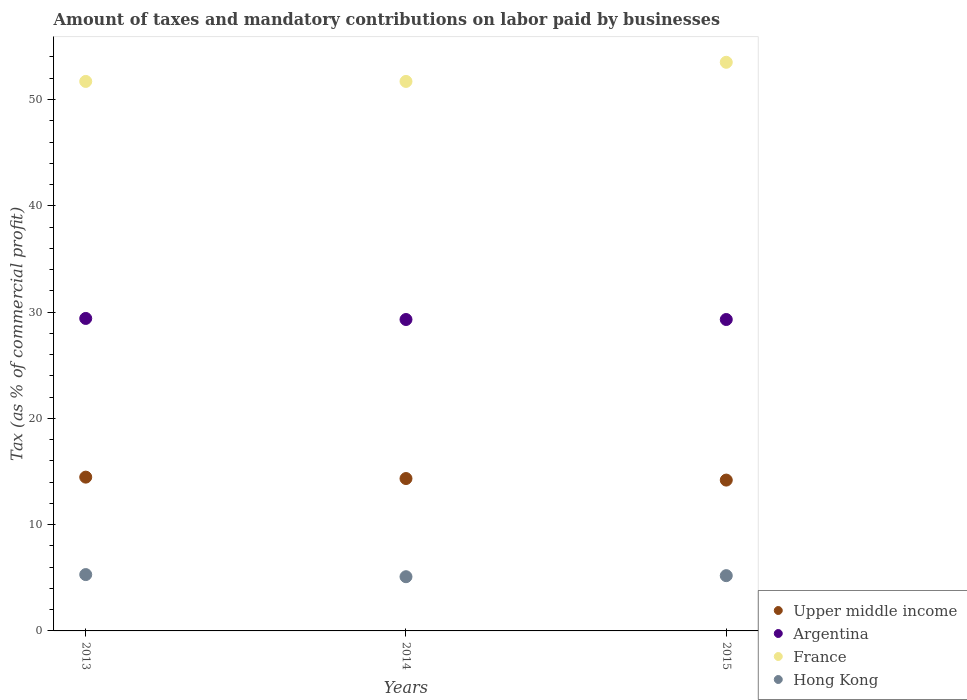What is the percentage of taxes paid by businesses in Hong Kong in 2013?
Your answer should be very brief. 5.3. Across all years, what is the maximum percentage of taxes paid by businesses in Hong Kong?
Offer a very short reply. 5.3. Across all years, what is the minimum percentage of taxes paid by businesses in France?
Give a very brief answer. 51.7. What is the total percentage of taxes paid by businesses in Upper middle income in the graph?
Your response must be concise. 43. What is the difference between the percentage of taxes paid by businesses in France in 2013 and that in 2014?
Offer a very short reply. 0. What is the difference between the percentage of taxes paid by businesses in Hong Kong in 2015 and the percentage of taxes paid by businesses in Upper middle income in 2014?
Provide a succinct answer. -9.14. What is the average percentage of taxes paid by businesses in Argentina per year?
Give a very brief answer. 29.33. In the year 2015, what is the difference between the percentage of taxes paid by businesses in Upper middle income and percentage of taxes paid by businesses in Argentina?
Give a very brief answer. -15.11. In how many years, is the percentage of taxes paid by businesses in Upper middle income greater than 32 %?
Provide a short and direct response. 0. What is the ratio of the percentage of taxes paid by businesses in Argentina in 2013 to that in 2015?
Your response must be concise. 1. Is the percentage of taxes paid by businesses in Hong Kong in 2013 less than that in 2014?
Your response must be concise. No. What is the difference between the highest and the second highest percentage of taxes paid by businesses in Hong Kong?
Keep it short and to the point. 0.1. What is the difference between the highest and the lowest percentage of taxes paid by businesses in Hong Kong?
Offer a terse response. 0.2. How many years are there in the graph?
Your response must be concise. 3. Does the graph contain grids?
Make the answer very short. No. How many legend labels are there?
Provide a short and direct response. 4. What is the title of the graph?
Provide a short and direct response. Amount of taxes and mandatory contributions on labor paid by businesses. What is the label or title of the Y-axis?
Provide a short and direct response. Tax (as % of commercial profit). What is the Tax (as % of commercial profit) in Upper middle income in 2013?
Your response must be concise. 14.47. What is the Tax (as % of commercial profit) in Argentina in 2013?
Your answer should be very brief. 29.4. What is the Tax (as % of commercial profit) of France in 2013?
Ensure brevity in your answer.  51.7. What is the Tax (as % of commercial profit) in Upper middle income in 2014?
Your response must be concise. 14.34. What is the Tax (as % of commercial profit) in Argentina in 2014?
Offer a terse response. 29.3. What is the Tax (as % of commercial profit) of France in 2014?
Your answer should be very brief. 51.7. What is the Tax (as % of commercial profit) in Hong Kong in 2014?
Offer a very short reply. 5.1. What is the Tax (as % of commercial profit) of Upper middle income in 2015?
Make the answer very short. 14.19. What is the Tax (as % of commercial profit) in Argentina in 2015?
Your response must be concise. 29.3. What is the Tax (as % of commercial profit) of France in 2015?
Offer a very short reply. 53.5. What is the Tax (as % of commercial profit) of Hong Kong in 2015?
Provide a succinct answer. 5.2. Across all years, what is the maximum Tax (as % of commercial profit) in Upper middle income?
Your answer should be very brief. 14.47. Across all years, what is the maximum Tax (as % of commercial profit) in Argentina?
Provide a short and direct response. 29.4. Across all years, what is the maximum Tax (as % of commercial profit) in France?
Offer a terse response. 53.5. Across all years, what is the maximum Tax (as % of commercial profit) in Hong Kong?
Ensure brevity in your answer.  5.3. Across all years, what is the minimum Tax (as % of commercial profit) of Upper middle income?
Give a very brief answer. 14.19. Across all years, what is the minimum Tax (as % of commercial profit) in Argentina?
Make the answer very short. 29.3. Across all years, what is the minimum Tax (as % of commercial profit) in France?
Ensure brevity in your answer.  51.7. Across all years, what is the minimum Tax (as % of commercial profit) in Hong Kong?
Provide a short and direct response. 5.1. What is the total Tax (as % of commercial profit) in Upper middle income in the graph?
Give a very brief answer. 43. What is the total Tax (as % of commercial profit) in Argentina in the graph?
Your answer should be very brief. 88. What is the total Tax (as % of commercial profit) of France in the graph?
Your response must be concise. 156.9. What is the total Tax (as % of commercial profit) of Hong Kong in the graph?
Offer a terse response. 15.6. What is the difference between the Tax (as % of commercial profit) of Upper middle income in 2013 and that in 2014?
Your response must be concise. 0.13. What is the difference between the Tax (as % of commercial profit) in Hong Kong in 2013 and that in 2014?
Your response must be concise. 0.2. What is the difference between the Tax (as % of commercial profit) of Upper middle income in 2013 and that in 2015?
Offer a terse response. 0.28. What is the difference between the Tax (as % of commercial profit) of France in 2013 and that in 2015?
Provide a short and direct response. -1.8. What is the difference between the Tax (as % of commercial profit) in Upper middle income in 2014 and that in 2015?
Your response must be concise. 0.15. What is the difference between the Tax (as % of commercial profit) in France in 2014 and that in 2015?
Offer a very short reply. -1.8. What is the difference between the Tax (as % of commercial profit) in Upper middle income in 2013 and the Tax (as % of commercial profit) in Argentina in 2014?
Keep it short and to the point. -14.83. What is the difference between the Tax (as % of commercial profit) in Upper middle income in 2013 and the Tax (as % of commercial profit) in France in 2014?
Provide a succinct answer. -37.23. What is the difference between the Tax (as % of commercial profit) in Upper middle income in 2013 and the Tax (as % of commercial profit) in Hong Kong in 2014?
Provide a succinct answer. 9.37. What is the difference between the Tax (as % of commercial profit) in Argentina in 2013 and the Tax (as % of commercial profit) in France in 2014?
Make the answer very short. -22.3. What is the difference between the Tax (as % of commercial profit) in Argentina in 2013 and the Tax (as % of commercial profit) in Hong Kong in 2014?
Offer a terse response. 24.3. What is the difference between the Tax (as % of commercial profit) of France in 2013 and the Tax (as % of commercial profit) of Hong Kong in 2014?
Your answer should be very brief. 46.6. What is the difference between the Tax (as % of commercial profit) of Upper middle income in 2013 and the Tax (as % of commercial profit) of Argentina in 2015?
Your answer should be compact. -14.83. What is the difference between the Tax (as % of commercial profit) in Upper middle income in 2013 and the Tax (as % of commercial profit) in France in 2015?
Your response must be concise. -39.03. What is the difference between the Tax (as % of commercial profit) in Upper middle income in 2013 and the Tax (as % of commercial profit) in Hong Kong in 2015?
Keep it short and to the point. 9.27. What is the difference between the Tax (as % of commercial profit) in Argentina in 2013 and the Tax (as % of commercial profit) in France in 2015?
Ensure brevity in your answer.  -24.1. What is the difference between the Tax (as % of commercial profit) in Argentina in 2013 and the Tax (as % of commercial profit) in Hong Kong in 2015?
Make the answer very short. 24.2. What is the difference between the Tax (as % of commercial profit) in France in 2013 and the Tax (as % of commercial profit) in Hong Kong in 2015?
Offer a very short reply. 46.5. What is the difference between the Tax (as % of commercial profit) in Upper middle income in 2014 and the Tax (as % of commercial profit) in Argentina in 2015?
Offer a very short reply. -14.96. What is the difference between the Tax (as % of commercial profit) of Upper middle income in 2014 and the Tax (as % of commercial profit) of France in 2015?
Give a very brief answer. -39.16. What is the difference between the Tax (as % of commercial profit) in Upper middle income in 2014 and the Tax (as % of commercial profit) in Hong Kong in 2015?
Provide a short and direct response. 9.14. What is the difference between the Tax (as % of commercial profit) in Argentina in 2014 and the Tax (as % of commercial profit) in France in 2015?
Ensure brevity in your answer.  -24.2. What is the difference between the Tax (as % of commercial profit) of Argentina in 2014 and the Tax (as % of commercial profit) of Hong Kong in 2015?
Your answer should be compact. 24.1. What is the difference between the Tax (as % of commercial profit) in France in 2014 and the Tax (as % of commercial profit) in Hong Kong in 2015?
Offer a very short reply. 46.5. What is the average Tax (as % of commercial profit) in Upper middle income per year?
Your answer should be compact. 14.33. What is the average Tax (as % of commercial profit) in Argentina per year?
Ensure brevity in your answer.  29.33. What is the average Tax (as % of commercial profit) of France per year?
Make the answer very short. 52.3. In the year 2013, what is the difference between the Tax (as % of commercial profit) in Upper middle income and Tax (as % of commercial profit) in Argentina?
Your response must be concise. -14.93. In the year 2013, what is the difference between the Tax (as % of commercial profit) in Upper middle income and Tax (as % of commercial profit) in France?
Your answer should be compact. -37.23. In the year 2013, what is the difference between the Tax (as % of commercial profit) in Upper middle income and Tax (as % of commercial profit) in Hong Kong?
Ensure brevity in your answer.  9.17. In the year 2013, what is the difference between the Tax (as % of commercial profit) in Argentina and Tax (as % of commercial profit) in France?
Your answer should be very brief. -22.3. In the year 2013, what is the difference between the Tax (as % of commercial profit) of Argentina and Tax (as % of commercial profit) of Hong Kong?
Provide a short and direct response. 24.1. In the year 2013, what is the difference between the Tax (as % of commercial profit) in France and Tax (as % of commercial profit) in Hong Kong?
Offer a very short reply. 46.4. In the year 2014, what is the difference between the Tax (as % of commercial profit) in Upper middle income and Tax (as % of commercial profit) in Argentina?
Offer a terse response. -14.96. In the year 2014, what is the difference between the Tax (as % of commercial profit) in Upper middle income and Tax (as % of commercial profit) in France?
Give a very brief answer. -37.36. In the year 2014, what is the difference between the Tax (as % of commercial profit) in Upper middle income and Tax (as % of commercial profit) in Hong Kong?
Your answer should be compact. 9.24. In the year 2014, what is the difference between the Tax (as % of commercial profit) in Argentina and Tax (as % of commercial profit) in France?
Provide a succinct answer. -22.4. In the year 2014, what is the difference between the Tax (as % of commercial profit) in Argentina and Tax (as % of commercial profit) in Hong Kong?
Offer a very short reply. 24.2. In the year 2014, what is the difference between the Tax (as % of commercial profit) in France and Tax (as % of commercial profit) in Hong Kong?
Provide a short and direct response. 46.6. In the year 2015, what is the difference between the Tax (as % of commercial profit) of Upper middle income and Tax (as % of commercial profit) of Argentina?
Your response must be concise. -15.11. In the year 2015, what is the difference between the Tax (as % of commercial profit) in Upper middle income and Tax (as % of commercial profit) in France?
Your answer should be compact. -39.31. In the year 2015, what is the difference between the Tax (as % of commercial profit) of Upper middle income and Tax (as % of commercial profit) of Hong Kong?
Offer a very short reply. 8.99. In the year 2015, what is the difference between the Tax (as % of commercial profit) of Argentina and Tax (as % of commercial profit) of France?
Offer a terse response. -24.2. In the year 2015, what is the difference between the Tax (as % of commercial profit) of Argentina and Tax (as % of commercial profit) of Hong Kong?
Provide a short and direct response. 24.1. In the year 2015, what is the difference between the Tax (as % of commercial profit) in France and Tax (as % of commercial profit) in Hong Kong?
Keep it short and to the point. 48.3. What is the ratio of the Tax (as % of commercial profit) in Upper middle income in 2013 to that in 2014?
Give a very brief answer. 1.01. What is the ratio of the Tax (as % of commercial profit) in Argentina in 2013 to that in 2014?
Your answer should be very brief. 1. What is the ratio of the Tax (as % of commercial profit) of Hong Kong in 2013 to that in 2014?
Keep it short and to the point. 1.04. What is the ratio of the Tax (as % of commercial profit) in Upper middle income in 2013 to that in 2015?
Give a very brief answer. 1.02. What is the ratio of the Tax (as % of commercial profit) in France in 2013 to that in 2015?
Keep it short and to the point. 0.97. What is the ratio of the Tax (as % of commercial profit) in Hong Kong in 2013 to that in 2015?
Give a very brief answer. 1.02. What is the ratio of the Tax (as % of commercial profit) of Upper middle income in 2014 to that in 2015?
Make the answer very short. 1.01. What is the ratio of the Tax (as % of commercial profit) in France in 2014 to that in 2015?
Offer a very short reply. 0.97. What is the ratio of the Tax (as % of commercial profit) in Hong Kong in 2014 to that in 2015?
Ensure brevity in your answer.  0.98. What is the difference between the highest and the second highest Tax (as % of commercial profit) of Upper middle income?
Offer a very short reply. 0.13. What is the difference between the highest and the second highest Tax (as % of commercial profit) in Argentina?
Offer a very short reply. 0.1. What is the difference between the highest and the second highest Tax (as % of commercial profit) of France?
Ensure brevity in your answer.  1.8. What is the difference between the highest and the second highest Tax (as % of commercial profit) of Hong Kong?
Make the answer very short. 0.1. What is the difference between the highest and the lowest Tax (as % of commercial profit) in Upper middle income?
Ensure brevity in your answer.  0.28. What is the difference between the highest and the lowest Tax (as % of commercial profit) in Argentina?
Your response must be concise. 0.1. What is the difference between the highest and the lowest Tax (as % of commercial profit) of France?
Offer a terse response. 1.8. What is the difference between the highest and the lowest Tax (as % of commercial profit) in Hong Kong?
Offer a terse response. 0.2. 